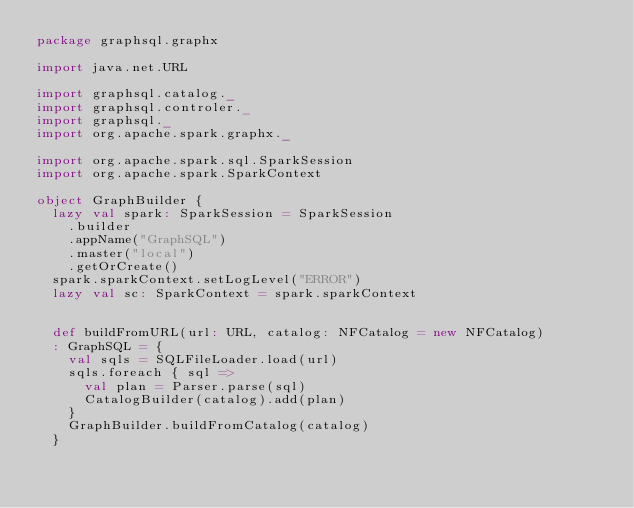<code> <loc_0><loc_0><loc_500><loc_500><_Scala_>package graphsql.graphx

import java.net.URL

import graphsql.catalog._
import graphsql.controler._
import graphsql._
import org.apache.spark.graphx._

import org.apache.spark.sql.SparkSession
import org.apache.spark.SparkContext

object GraphBuilder {
  lazy val spark: SparkSession = SparkSession
    .builder
    .appName("GraphSQL")
    .master("local")
    .getOrCreate()
  spark.sparkContext.setLogLevel("ERROR")
  lazy val sc: SparkContext = spark.sparkContext


  def buildFromURL(url: URL, catalog: NFCatalog = new NFCatalog)
  : GraphSQL = {
    val sqls = SQLFileLoader.load(url)
    sqls.foreach { sql =>
      val plan = Parser.parse(sql)
      CatalogBuilder(catalog).add(plan)
    }
    GraphBuilder.buildFromCatalog(catalog)
  }
</code> 